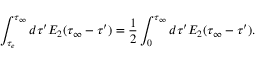Convert formula to latex. <formula><loc_0><loc_0><loc_500><loc_500>\int _ { \tau _ { e } } ^ { \tau _ { \infty } } d \tau ^ { \prime } E _ { 2 } ( \tau _ { \infty } - \tau ^ { \prime } ) = { \frac { 1 } { 2 } } \int _ { 0 } ^ { \tau _ { \infty } } d \tau ^ { \prime } E _ { 2 } ( \tau _ { \infty } - \tau ^ { \prime } ) .</formula> 